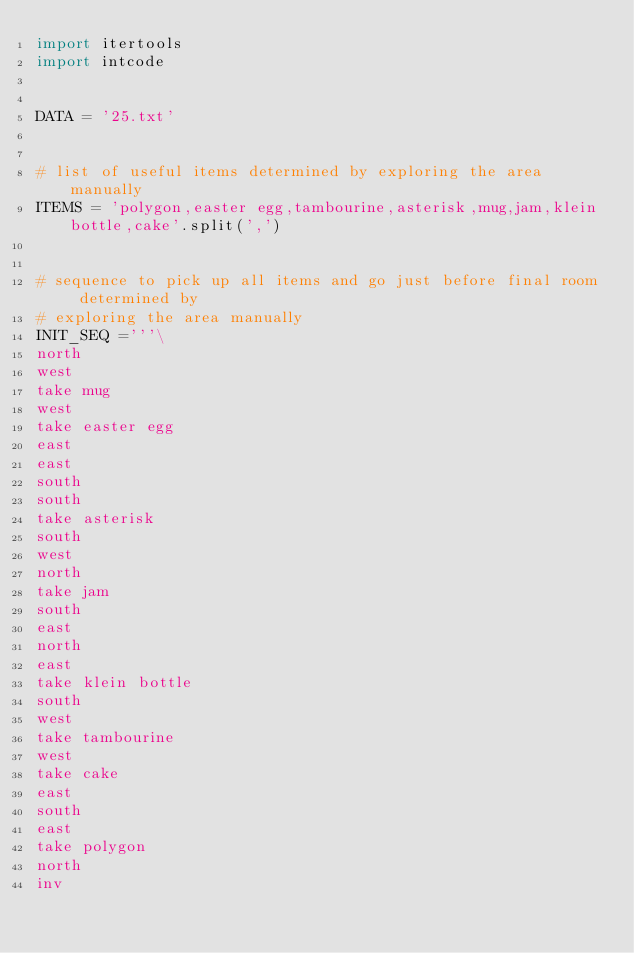<code> <loc_0><loc_0><loc_500><loc_500><_Python_>import itertools
import intcode


DATA = '25.txt'


# list of useful items determined by exploring the area manually
ITEMS = 'polygon,easter egg,tambourine,asterisk,mug,jam,klein bottle,cake'.split(',')


# sequence to pick up all items and go just before final room  determined by
# exploring the area manually
INIT_SEQ ='''\
north
west
take mug
west
take easter egg
east
east
south
south
take asterisk
south
west
north
take jam
south
east
north
east
take klein bottle
south
west
take tambourine
west
take cake
east
south
east
take polygon
north
inv</code> 